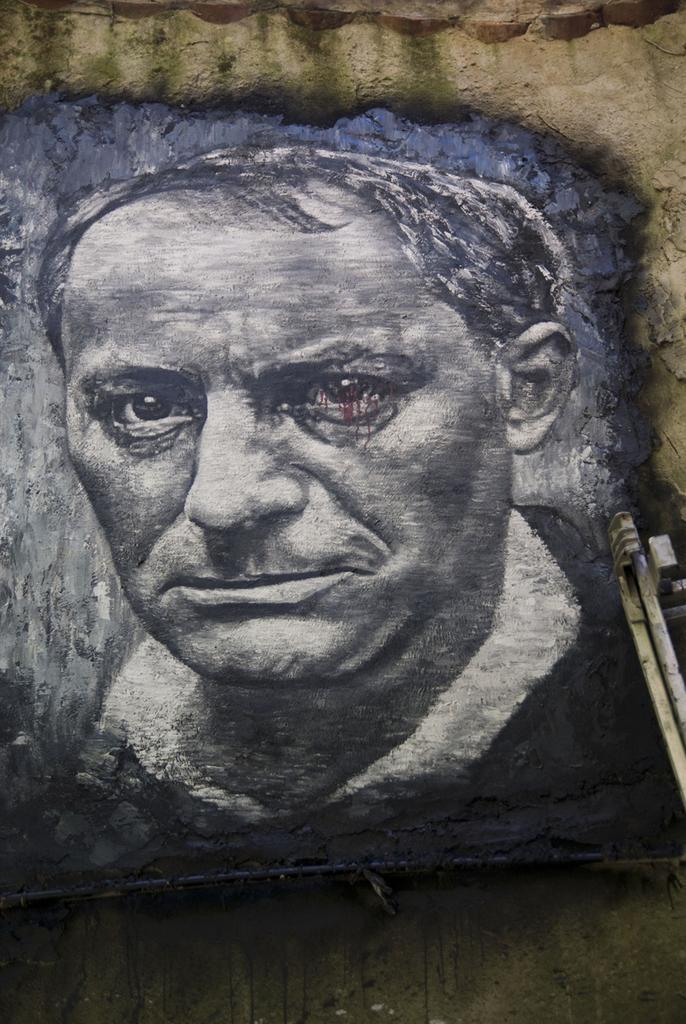In one or two sentences, can you explain what this image depicts? In the image there is a painting of a man on the surface. 